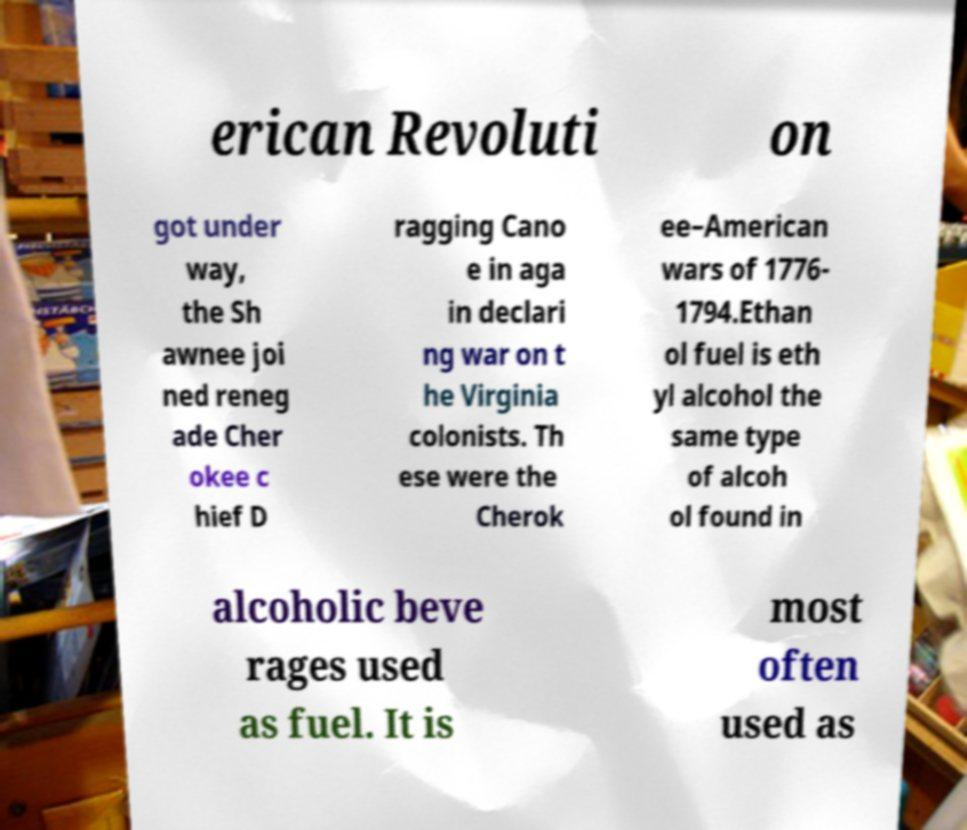Could you assist in decoding the text presented in this image and type it out clearly? erican Revoluti on got under way, the Sh awnee joi ned reneg ade Cher okee c hief D ragging Cano e in aga in declari ng war on t he Virginia colonists. Th ese were the Cherok ee–American wars of 1776- 1794.Ethan ol fuel is eth yl alcohol the same type of alcoh ol found in alcoholic beve rages used as fuel. It is most often used as 